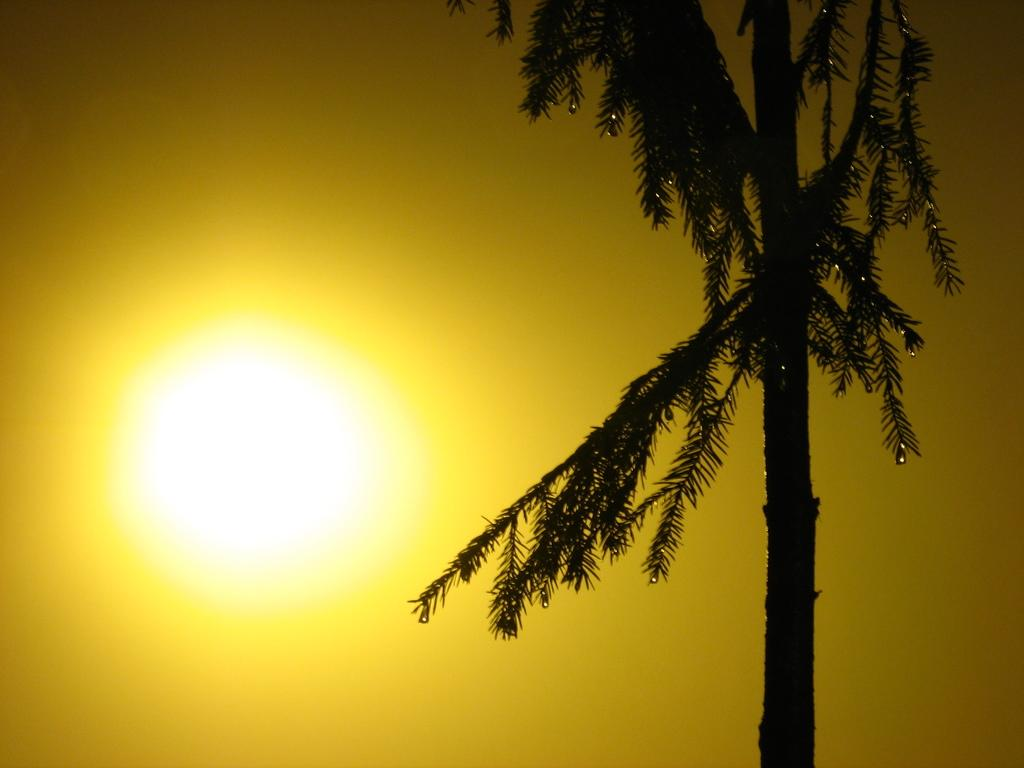What is located at the front of the image? There is a tree in the front of the image. What can be seen in the sky in the background of the image? The sun is visible in the sky in the background of the image. What type of fuel is being used by the person in the image? There is no person present in the image, so it is not possible to determine what type of fuel they might be using. 